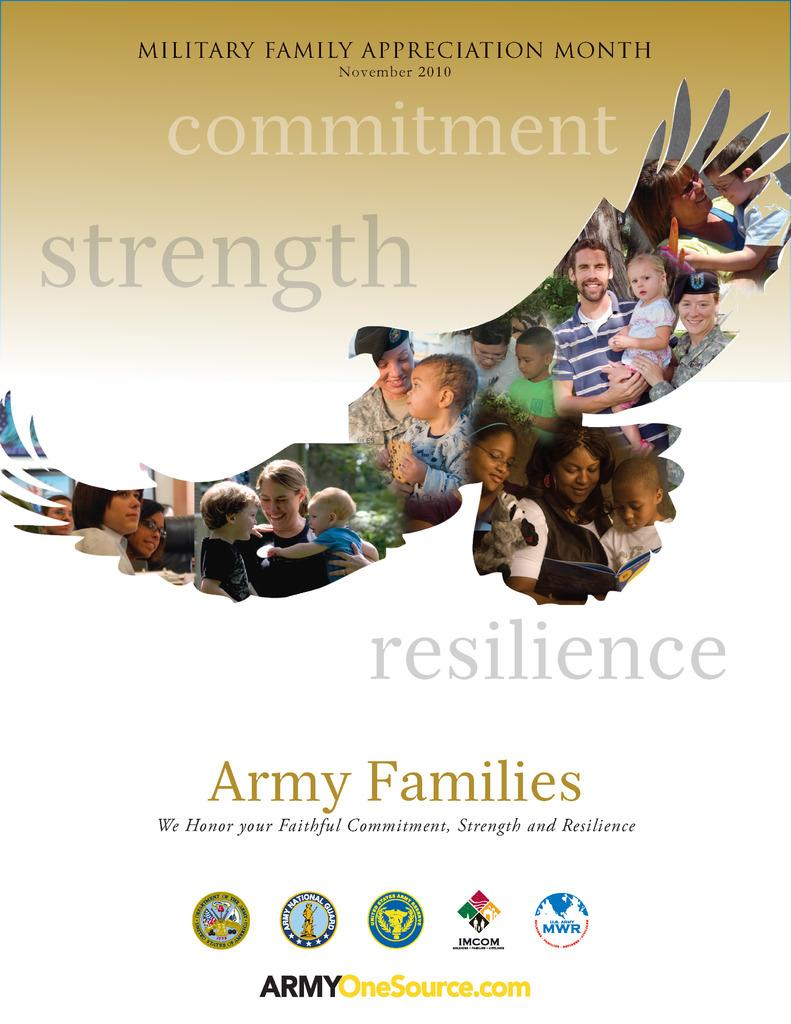What type of visual is the image? The image is a poster. What elements are present on the poster? The poster contains texts, logos, and an image of a bird. Can you describe the image of the bird? The poster has an image of a bird. Are there any people depicted on the poster? Yes, there are persons in the image, including children. What type of pen is being used by the girls in the image? There are no girls or pens present in the image. 